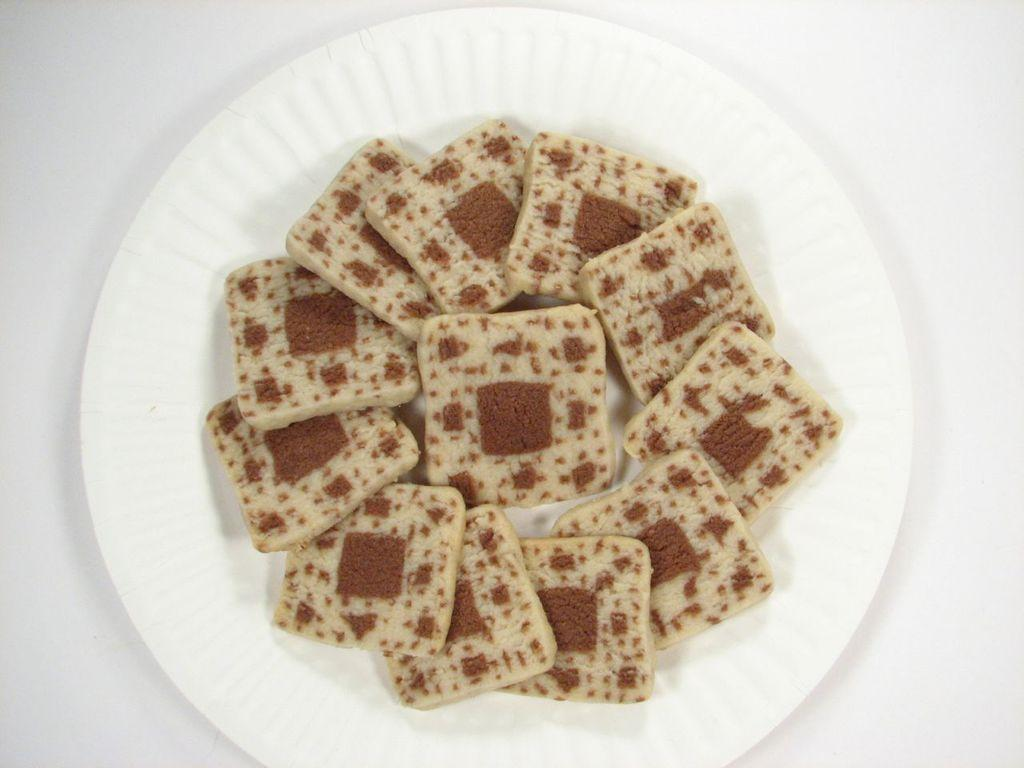What type of food can be seen in the image? The food in the image is in cream and brown colors. How is the food arranged in the image? The food is in a plate. What color is the plate? The plate is white. Can you see any spots on the body of the person in the image? There is no person present in the image, only food in a plate. What type of error can be seen in the image? There is no error present in the image; it shows a plate of food with cream and brown colors. 